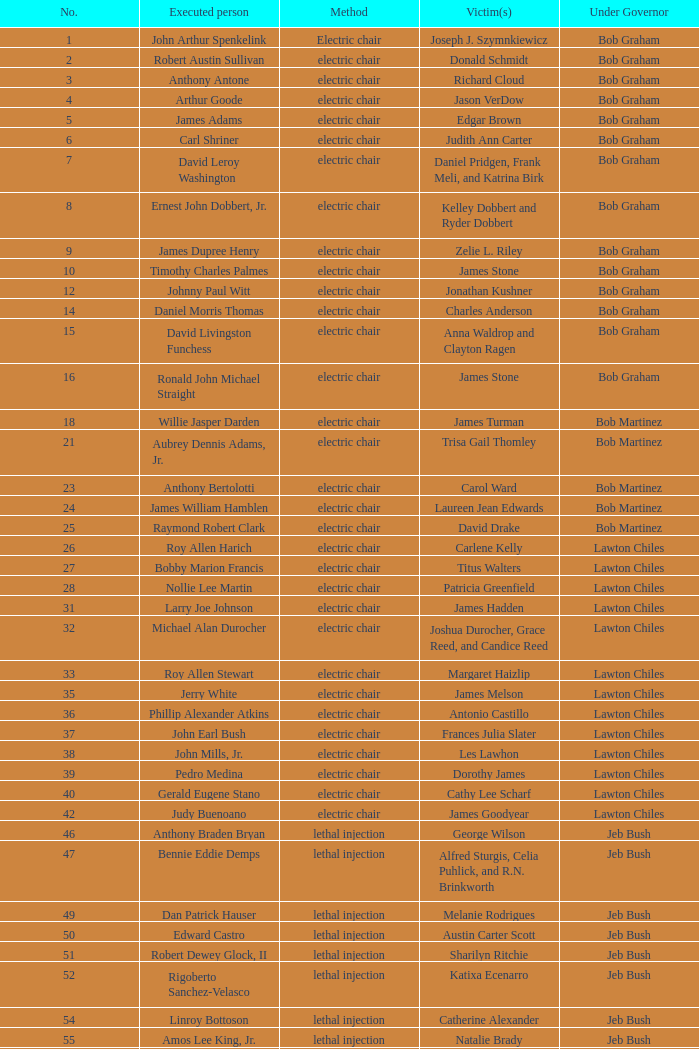What's the name of Linroy Bottoson's victim? Catherine Alexander. 